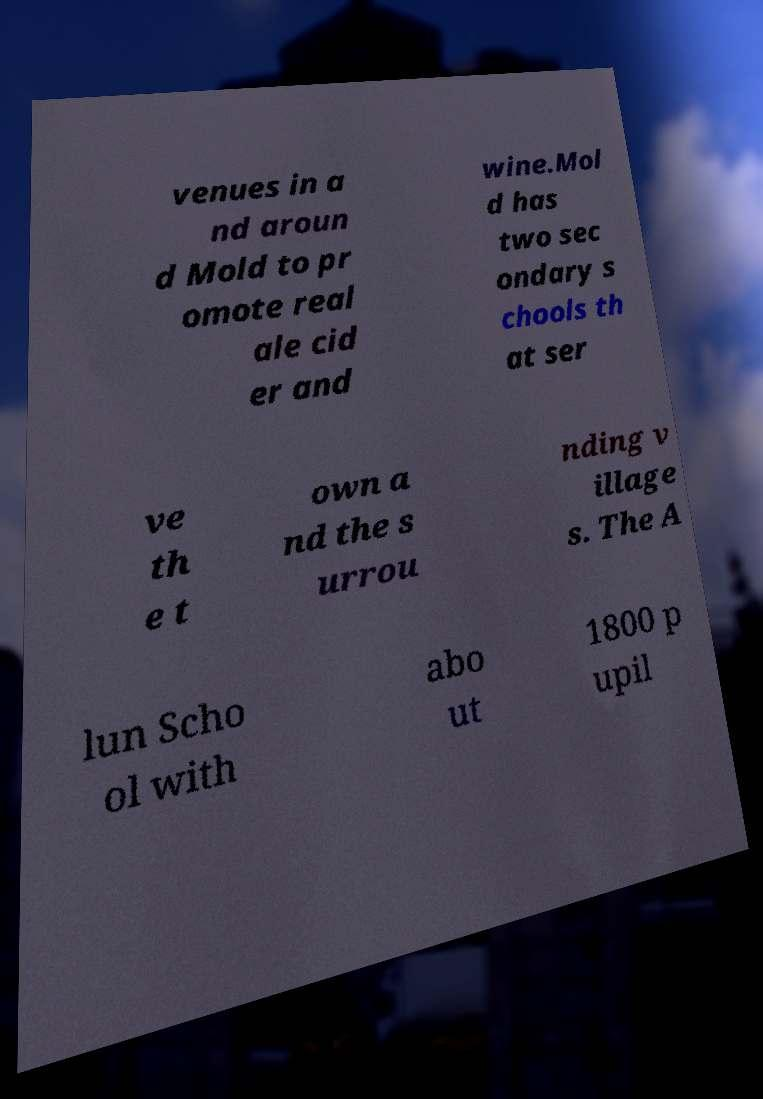Could you extract and type out the text from this image? venues in a nd aroun d Mold to pr omote real ale cid er and wine.Mol d has two sec ondary s chools th at ser ve th e t own a nd the s urrou nding v illage s. The A lun Scho ol with abo ut 1800 p upil 